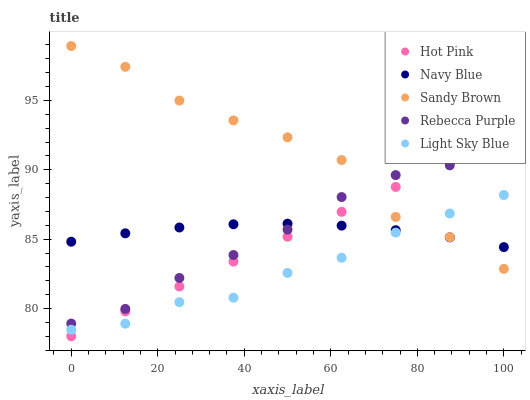Does Light Sky Blue have the minimum area under the curve?
Answer yes or no. Yes. Does Sandy Brown have the maximum area under the curve?
Answer yes or no. Yes. Does Hot Pink have the minimum area under the curve?
Answer yes or no. No. Does Hot Pink have the maximum area under the curve?
Answer yes or no. No. Is Hot Pink the smoothest?
Answer yes or no. Yes. Is Sandy Brown the roughest?
Answer yes or no. Yes. Is Sandy Brown the smoothest?
Answer yes or no. No. Is Hot Pink the roughest?
Answer yes or no. No. Does Hot Pink have the lowest value?
Answer yes or no. Yes. Does Sandy Brown have the lowest value?
Answer yes or no. No. Does Sandy Brown have the highest value?
Answer yes or no. Yes. Does Hot Pink have the highest value?
Answer yes or no. No. Is Light Sky Blue less than Rebecca Purple?
Answer yes or no. Yes. Is Rebecca Purple greater than Light Sky Blue?
Answer yes or no. Yes. Does Sandy Brown intersect Light Sky Blue?
Answer yes or no. Yes. Is Sandy Brown less than Light Sky Blue?
Answer yes or no. No. Is Sandy Brown greater than Light Sky Blue?
Answer yes or no. No. Does Light Sky Blue intersect Rebecca Purple?
Answer yes or no. No. 